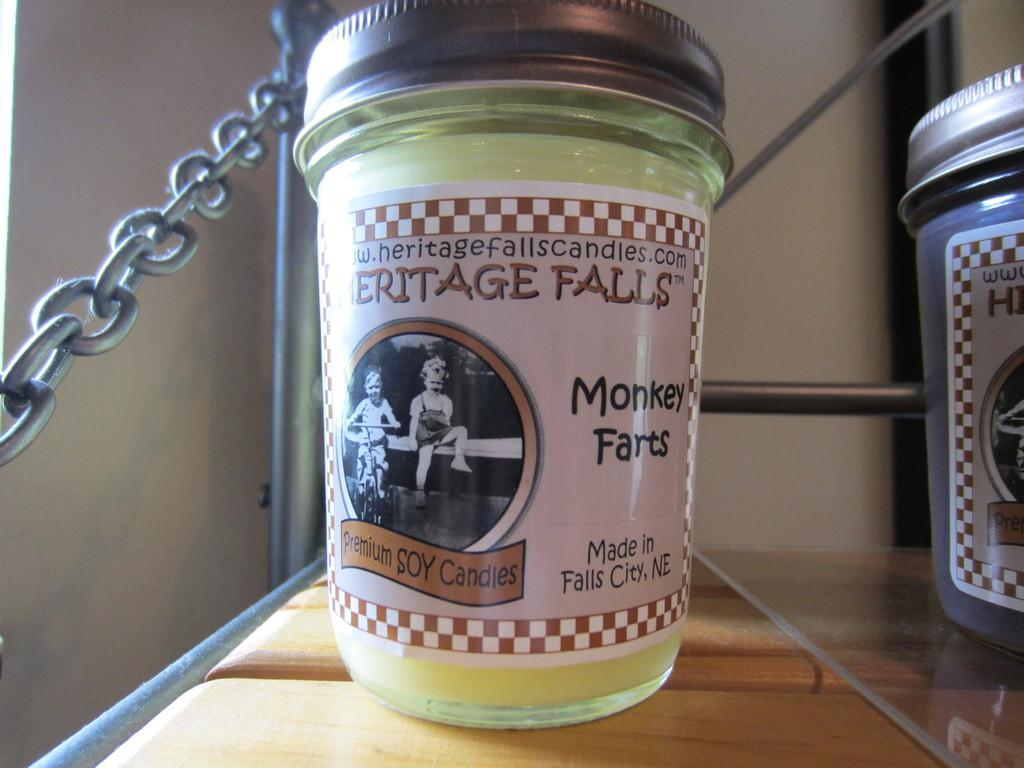<image>
Share a concise interpretation of the image provided. A Monkey Farts soy candle from Heritage Falls sits on a shelf 